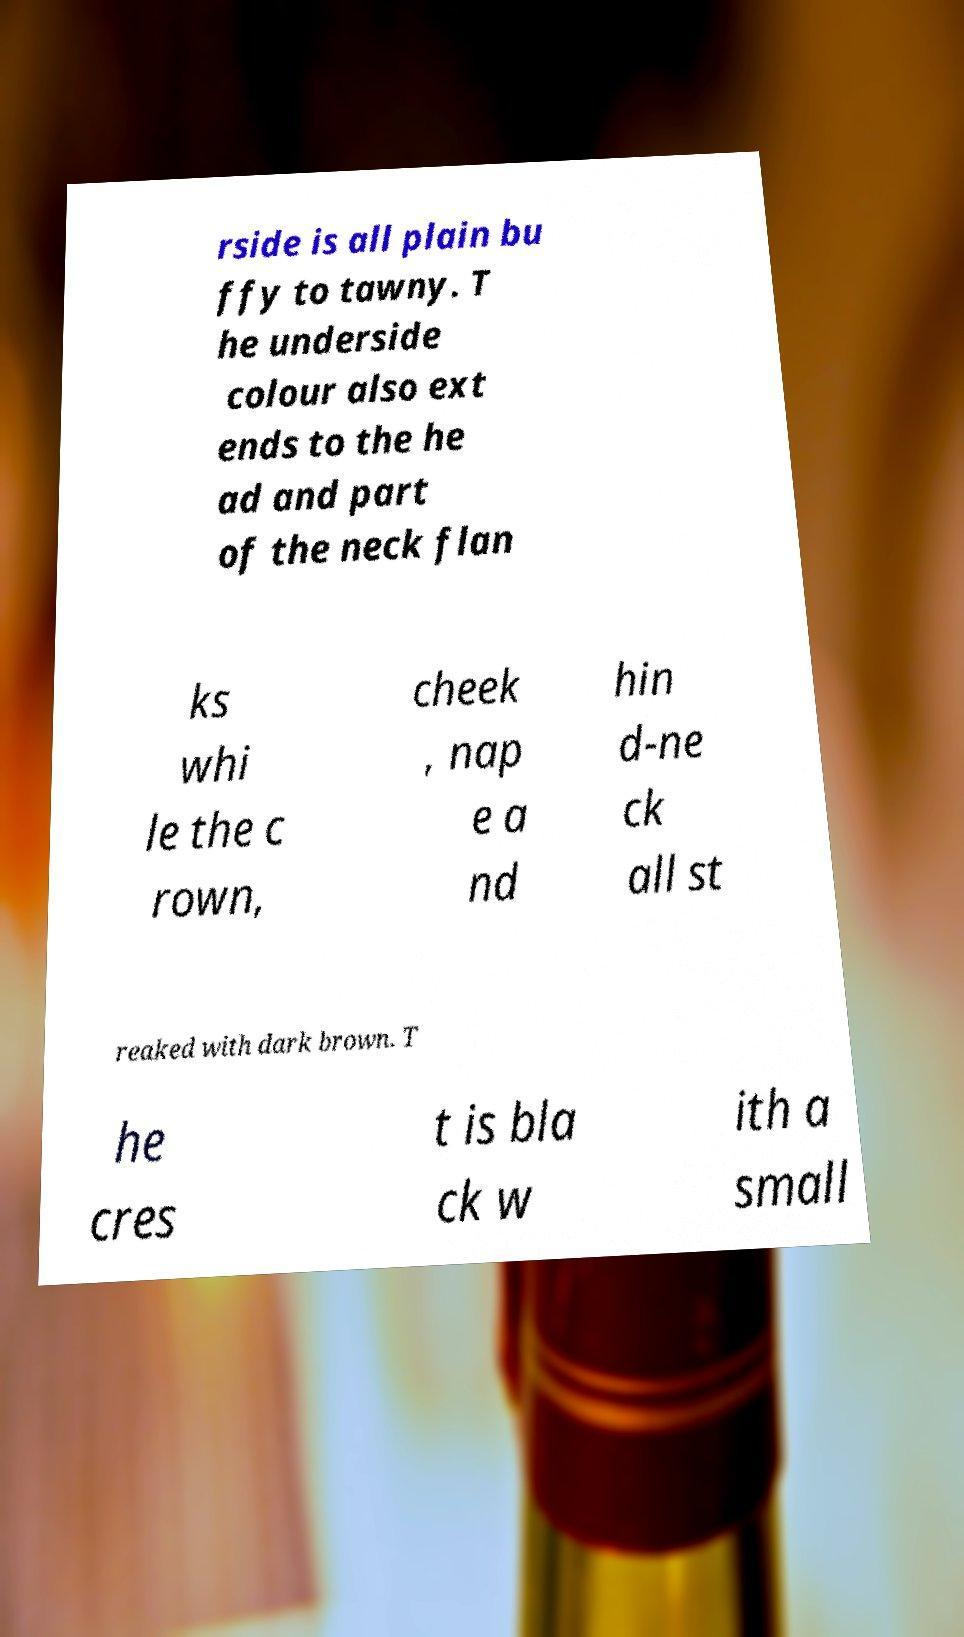Can you read and provide the text displayed in the image?This photo seems to have some interesting text. Can you extract and type it out for me? rside is all plain bu ffy to tawny. T he underside colour also ext ends to the he ad and part of the neck flan ks whi le the c rown, cheek , nap e a nd hin d-ne ck all st reaked with dark brown. T he cres t is bla ck w ith a small 